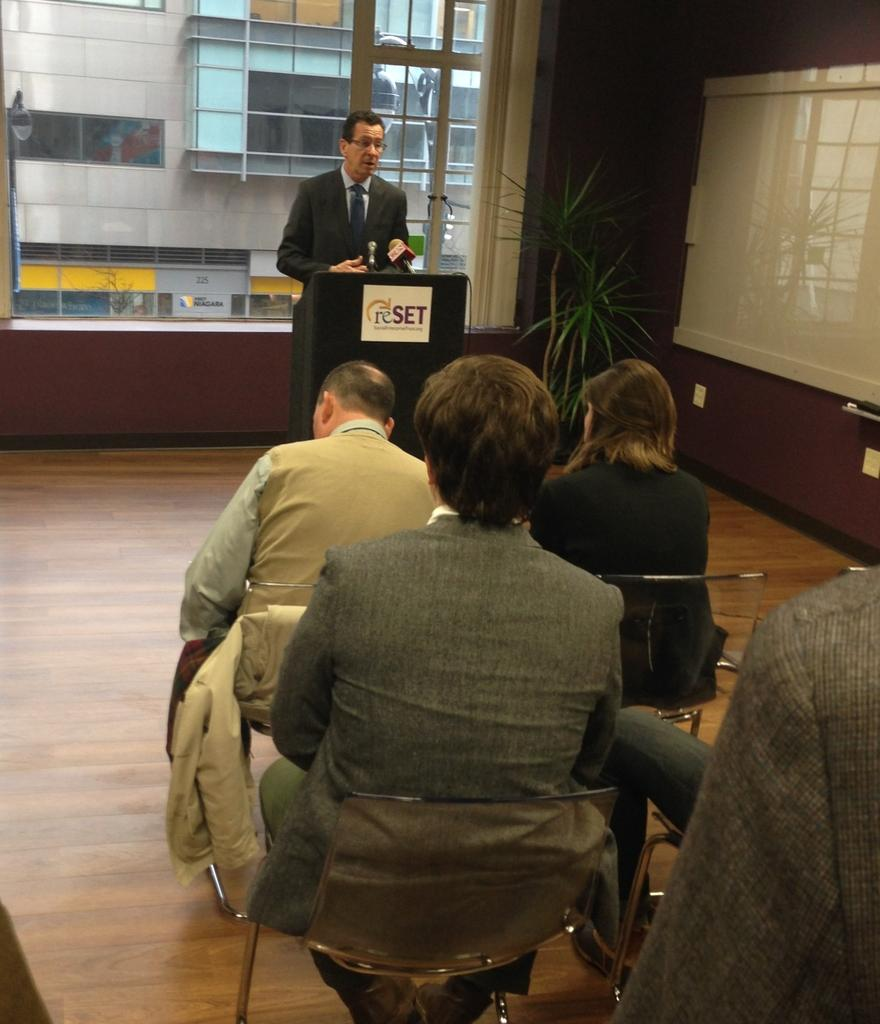How many people are in the image? There are people in the image, but the exact number is not specified. What are some of the people doing in the image? Some people are sitting on chairs, and one person is standing. What type of plant is in the image? The fact does not specify the type of plant, only that there is a plant present. What is the whiteboard used for in the image? The purpose of the whiteboard is not specified in the facts. What type of building is in the image? The fact only mentions that there is a building in the image, not its type. What type of education can be seen being provided to the children by their parent in the image? There is no mention of children, parents, or education in the image. The facts only mention people, chairs, a standing person, a plant, a whiteboard, and a building. 